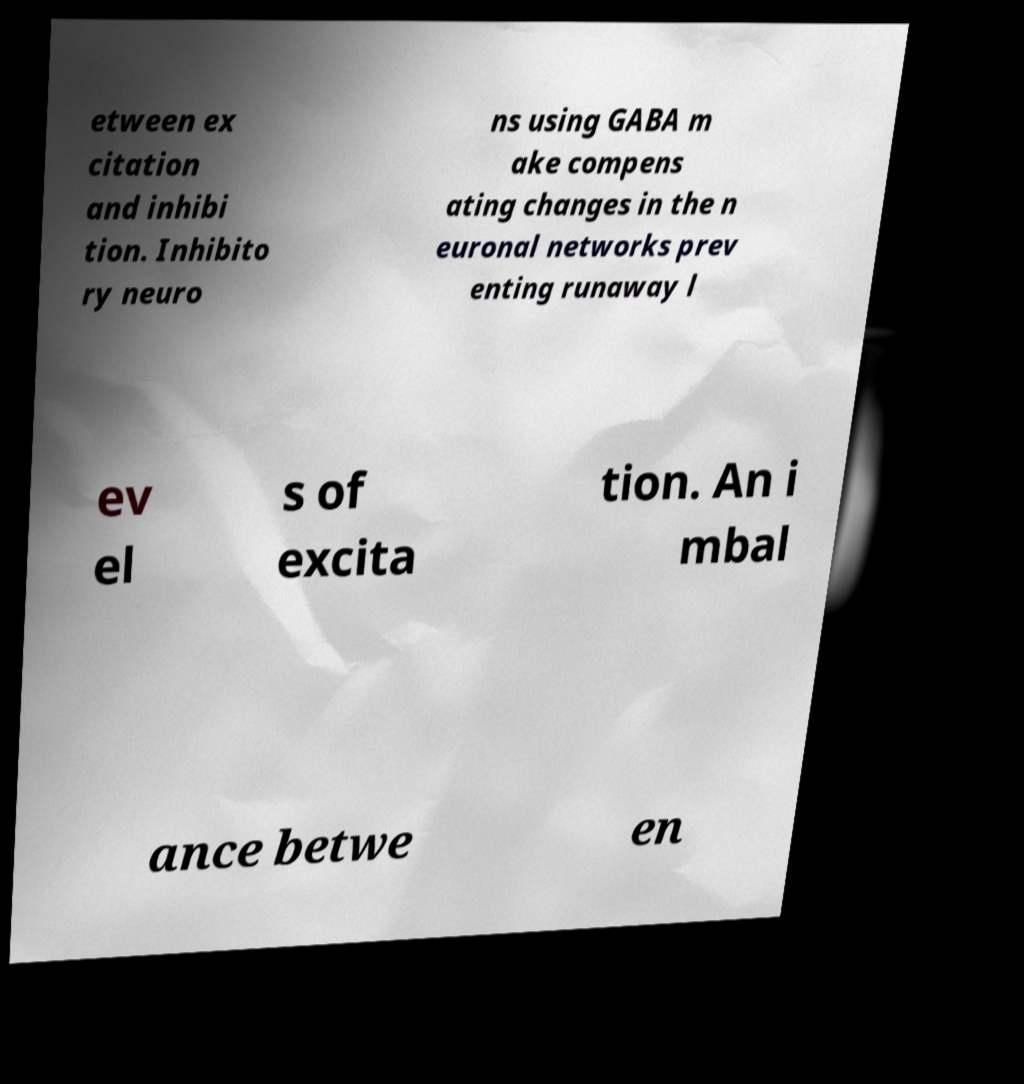Can you read and provide the text displayed in the image?This photo seems to have some interesting text. Can you extract and type it out for me? etween ex citation and inhibi tion. Inhibito ry neuro ns using GABA m ake compens ating changes in the n euronal networks prev enting runaway l ev el s of excita tion. An i mbal ance betwe en 